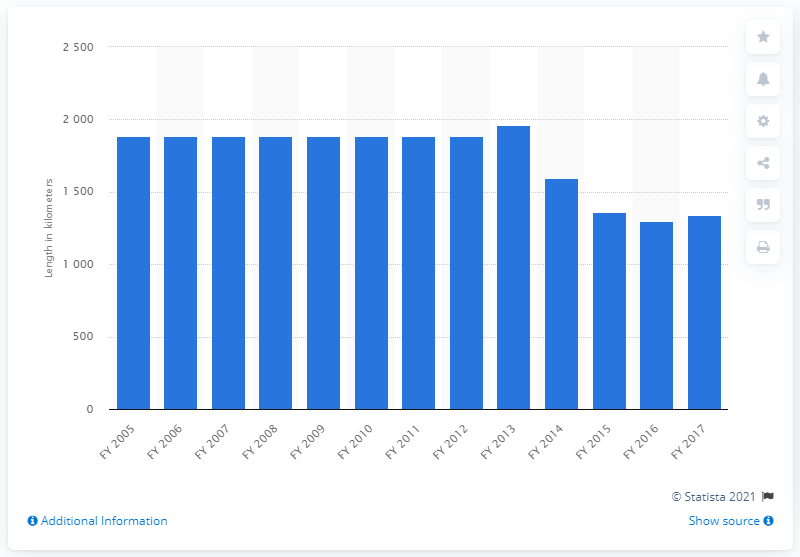Draw attention to some important aspects in this diagram. As of 2017, the total length of state highways in Jharkhand was 1,296 kilometers. 